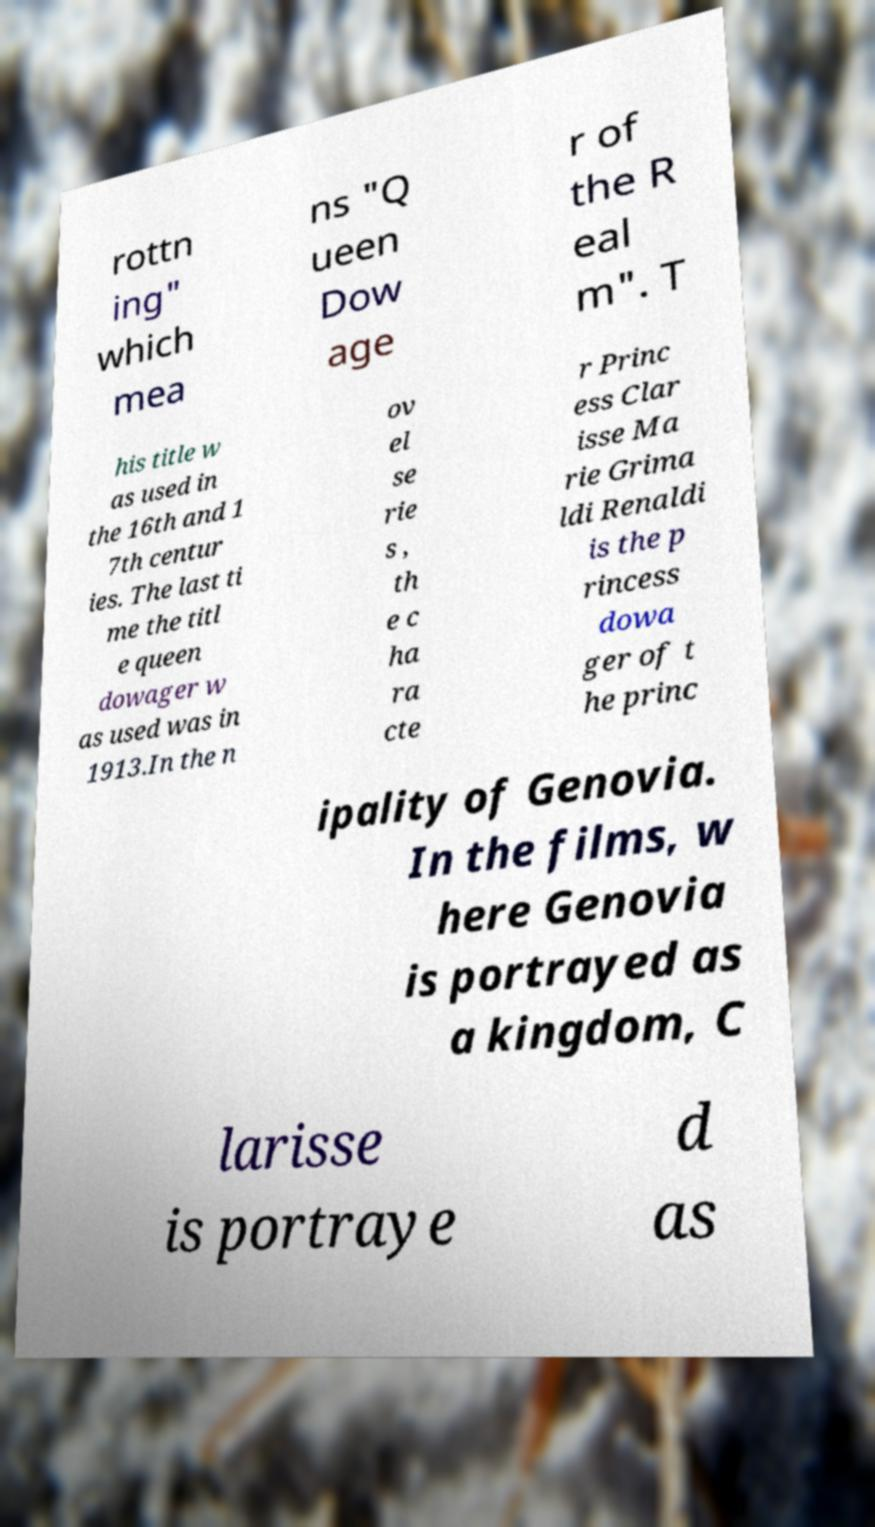Could you extract and type out the text from this image? rottn ing" which mea ns "Q ueen Dow age r of the R eal m". T his title w as used in the 16th and 1 7th centur ies. The last ti me the titl e queen dowager w as used was in 1913.In the n ov el se rie s , th e c ha ra cte r Princ ess Clar isse Ma rie Grima ldi Renaldi is the p rincess dowa ger of t he princ ipality of Genovia. In the films, w here Genovia is portrayed as a kingdom, C larisse is portraye d as 